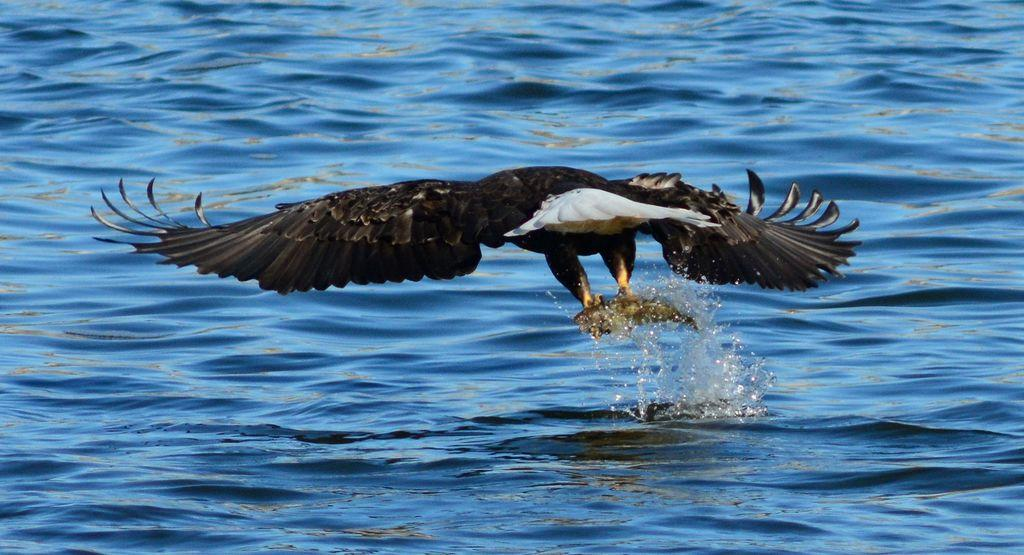What type of animal can be seen in the image? There is a bird in the image. What is the bird doing in the image? The bird is flying. What natural feature is present in the image? There is a river in the image. Where is the son shopping for groceries in the image? There is no son or shopping activity present in the image; it features a bird flying and a river. 